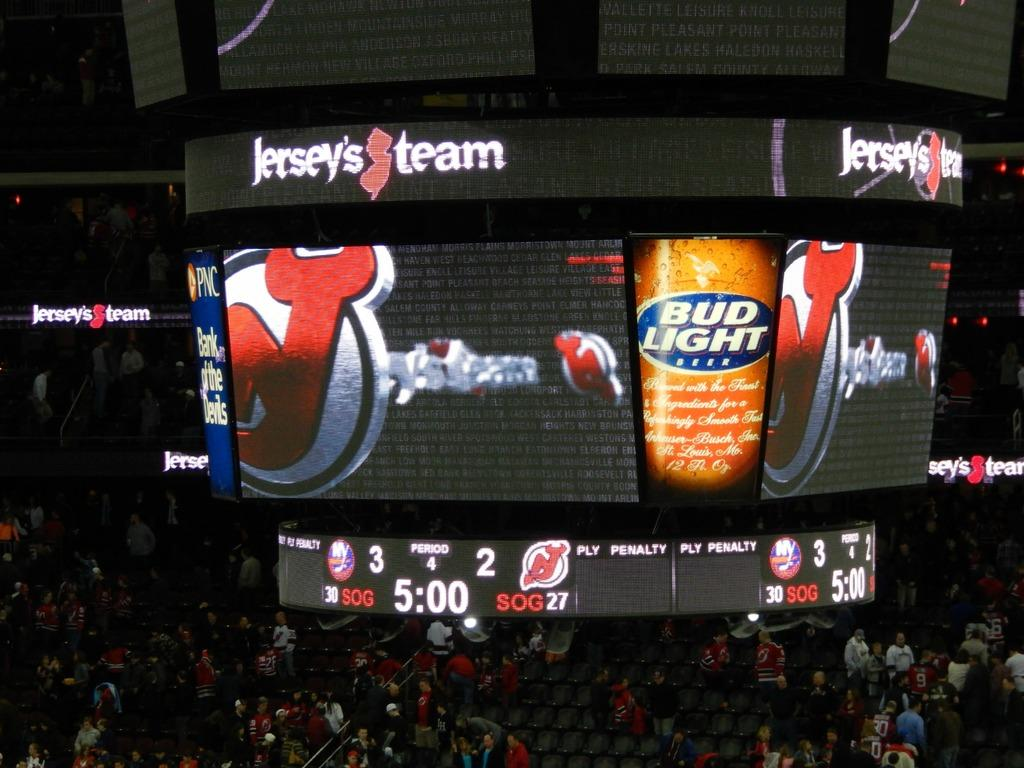<image>
Write a terse but informative summary of the picture. A hanging jumbo tron with an ad for bud lite on one of its sides. 